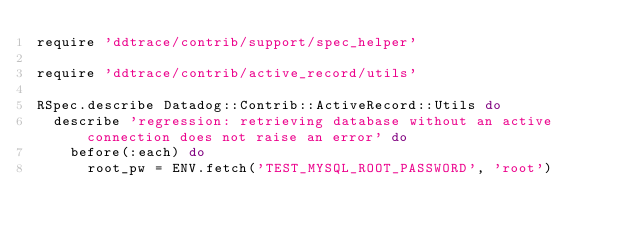<code> <loc_0><loc_0><loc_500><loc_500><_Ruby_>require 'ddtrace/contrib/support/spec_helper'

require 'ddtrace/contrib/active_record/utils'

RSpec.describe Datadog::Contrib::ActiveRecord::Utils do
  describe 'regression: retrieving database without an active connection does not raise an error' do
    before(:each) do
      root_pw = ENV.fetch('TEST_MYSQL_ROOT_PASSWORD', 'root')</code> 